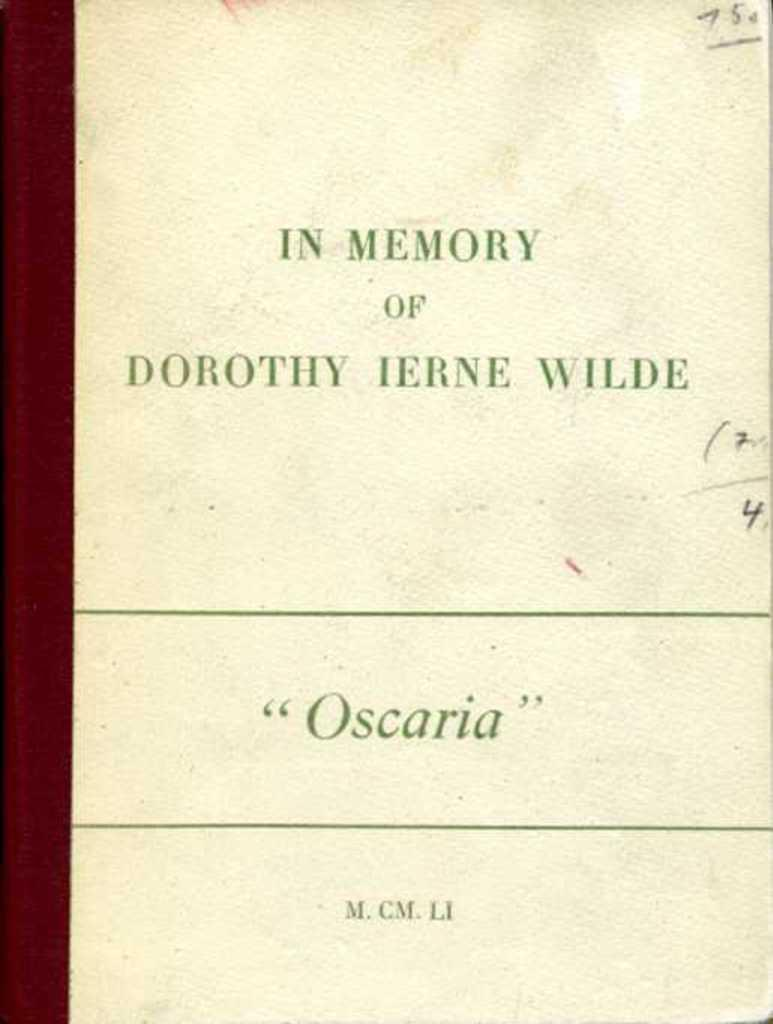<image>
Write a terse but informative summary of the picture. A book dedication is written above the title "Oscaria" on a slightly dirty page. 